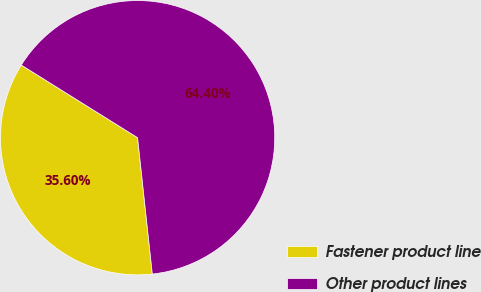<chart> <loc_0><loc_0><loc_500><loc_500><pie_chart><fcel>Fastener product line<fcel>Other product lines<nl><fcel>35.6%<fcel>64.4%<nl></chart> 